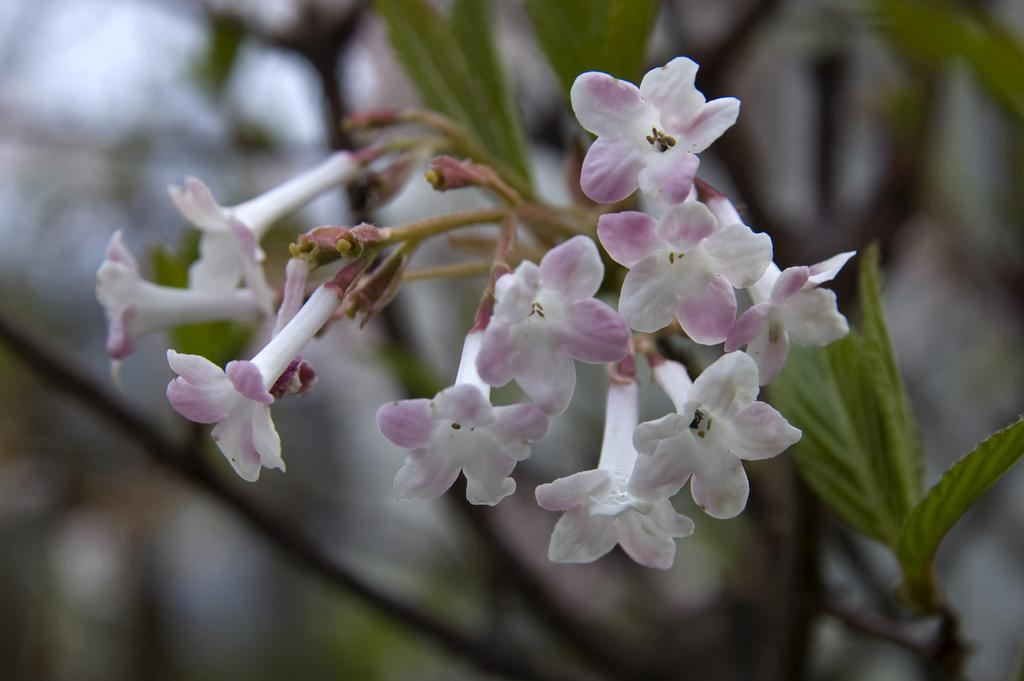What is the main subject of the image? The main subject of the image is a bunch of flowers. Where are the flowers located on the plant? The flowers are on the stem of the plant. What type of stew is being prepared in the image? There is no stew present in the image; it features a bunch of flowers on the stem of a plant. How does the texture of the flowers change as they grow in the image? The image does not show the flowers growing or changing texture; it only shows a bunch of flowers on the stem of a plant. 